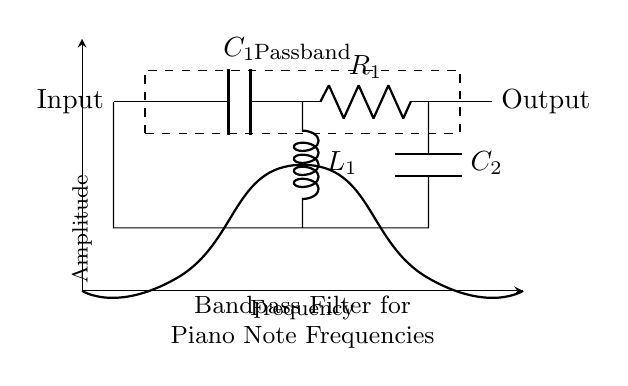What type of filter is represented in the circuit? The circuit is a bandpass filter, which is indicated by the label in the diagram and is designed to allow frequencies within a specific range to pass while attenuating frequencies outside that range.
Answer: Bandpass filter What are the components used in this circuit? The components used are two capacitors (C1 and C2), one inductor (L1), and one resistor (R1), as evident from their representations in the circuit.
Answer: Capacitors, inductor, and resistor What is the main function of the inductor in this filter? The inductor's primary role in a bandpass filter is to block high-frequency signals while allowing lower frequencies to pass, thereby contributing to the filter's overall frequency response.
Answer: To block high frequencies How many capacitors are present in the circuit? There are two capacitors shown in the circuit diagram, labeled as C1 and C2, which can be directly observed in the diagram.
Answer: Two What is the output of the filter related to piano notes? The output is focused on enhancing specific piano note frequencies, as indicated by the circuit's label suggesting its purpose in treating audio signals relevant to piano notes.
Answer: Enhancing piano note frequencies What defines the passband in this bandpass filter? The passband is defined by the range of frequencies that can pass through the circuit unattenuated, which is typically determined by the values of the capacitors and inductor. The visual marking in the diagram highlights this area.
Answer: Passband marked in the diagram How is the output voltage connected in this circuit? The output voltage is taken directly from the point where the resistor (R1) meets the two capacitors, providing access to the filtered signal.
Answer: Connected at the output of R1 